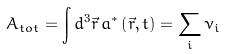Convert formula to latex. <formula><loc_0><loc_0><loc_500><loc_500>A _ { t o t } = \int d ^ { 3 } \vec { r } \, a ^ { \ast } \left ( \vec { r } , t \right ) = \sum _ { i } \nu _ { i }</formula> 